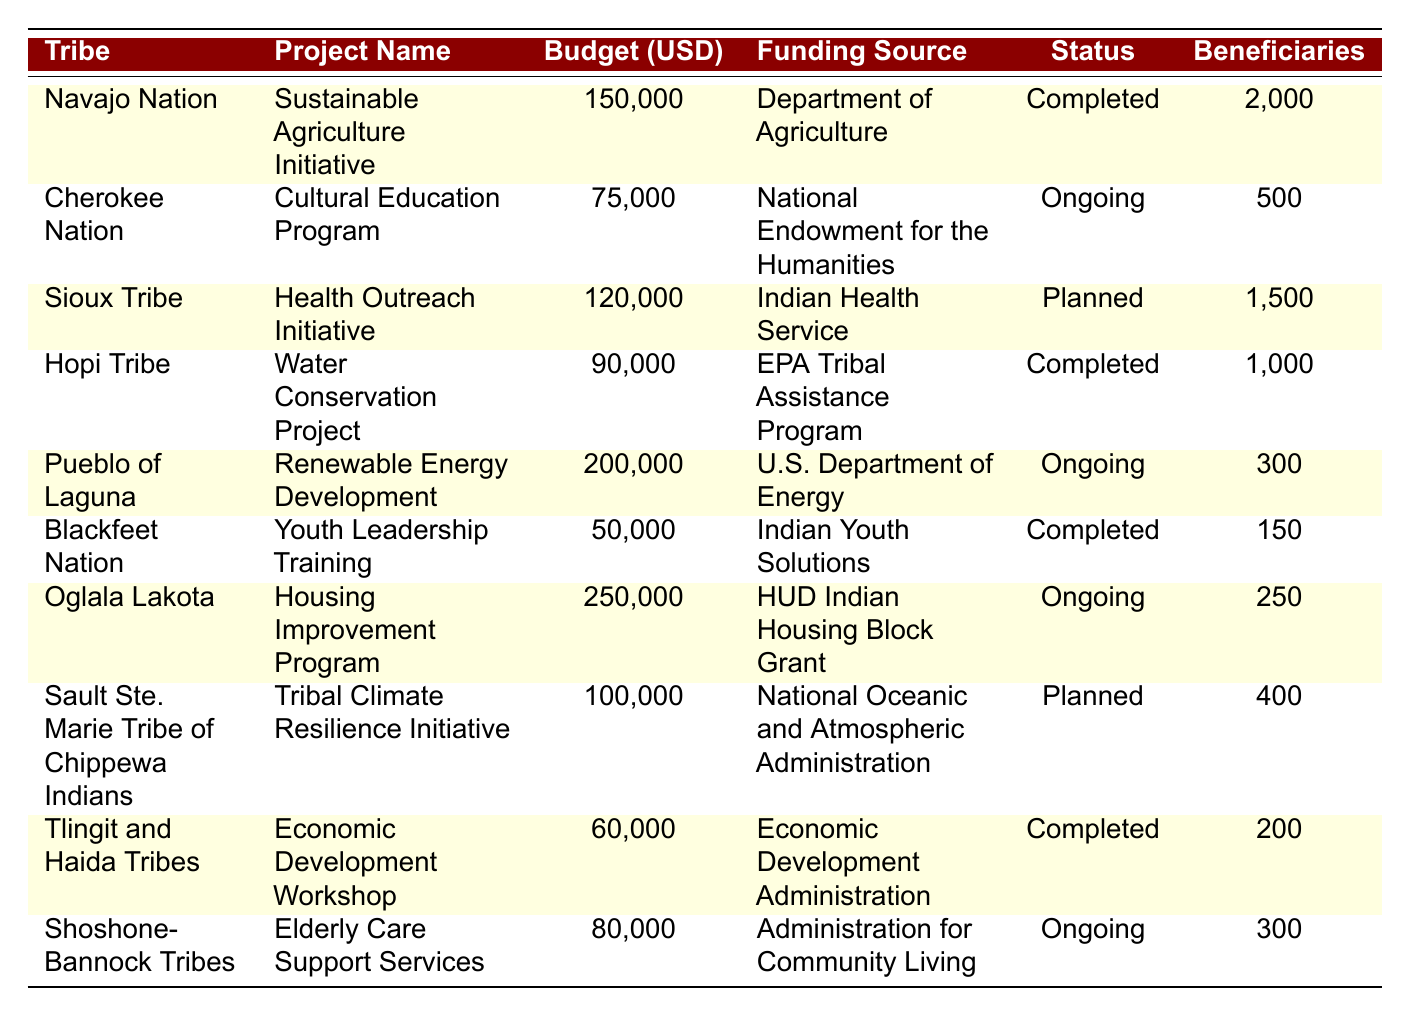What is the allocated budget for the Health Outreach Initiative by the Sioux Tribe? From the table, locate the row corresponding to the Sioux Tribe and find the "allocatedBudgetUSD" value, which is 120000.
Answer: 120000 Which tribe has the highest number of beneficiaries? By reviewing the "beneficiaries" column, the Oglala Lakota with 250 beneficiaries is less than the Navajo Nation's 2000 beneficiaries, making it the highest.
Answer: Navajo Nation What is the average budget allocated for the ongoing projects? Identify the ongoing projects: Cherokee Nation (75000), Pueblo of Laguna (200000), Oglala Lakota (250000), Shoshone-Bannock Tribes (80000). Sum these budgets (75000 + 200000 + 250000 + 80000) = 505000 and divide by 4 projects: 505000/4 = 126250.
Answer: 126250 Is the Economic Development Workshop completed? From the project's "projectStatus", it shows "Completed".
Answer: Yes Which tribe received funding from the Department of Agriculture? Checking the "Funding Source" column, it lists the Department of Agriculture associated with the Navajo Nation's project.
Answer: Navajo Nation What is the total number of beneficiaries across all completed projects? First, identify completed projects and their beneficiaries: Navajo Nation (2000), Hopi Tribe (1000), Blackfeet Nation (150), Tlingit and Haida Tribes (200). Sum these beneficiaries (2000 + 1000 + 150 + 200) = 3350.
Answer: 3350 Did the Sioux Tribe receive more funding than the Blackfeet Nation? Compare the "allocatedBudgetUSD" for Sioux Tribe (120000) and Blackfeet Nation (50000); since 120000 is greater than 50000, the statement is true.
Answer: Yes Which project has the smallest allocated budget? Examine the "allocatedBudgetUSD" values and find that the Youth Leadership Training by Blackfeet Nation has the smallest budget of 50000.
Answer: Youth Leadership Training How many different funding sources are mentioned in the table? Identify unique funding sources from the table: Department of Agriculture, National Endowment for the Humanities, Indian Health Service, EPA Tribal Assistance Program, U.S. Department of Energy, Indian Youth Solutions, HUD Indian Housing Block Grant, National Oceanic and Atmospheric Administration, Economic Development Administration, Administration for Community Living. This totals to 10 different sources.
Answer: 10 